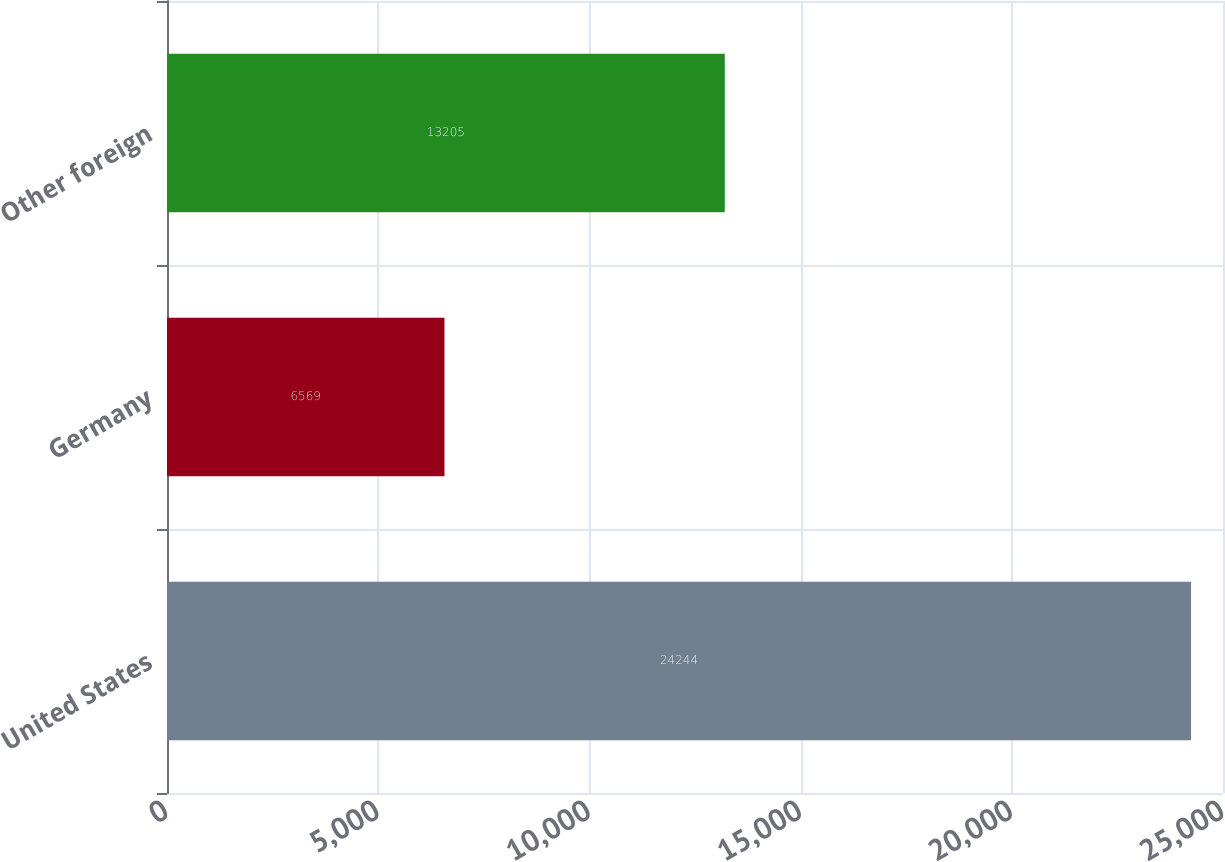Convert chart. <chart><loc_0><loc_0><loc_500><loc_500><bar_chart><fcel>United States<fcel>Germany<fcel>Other foreign<nl><fcel>24244<fcel>6569<fcel>13205<nl></chart> 